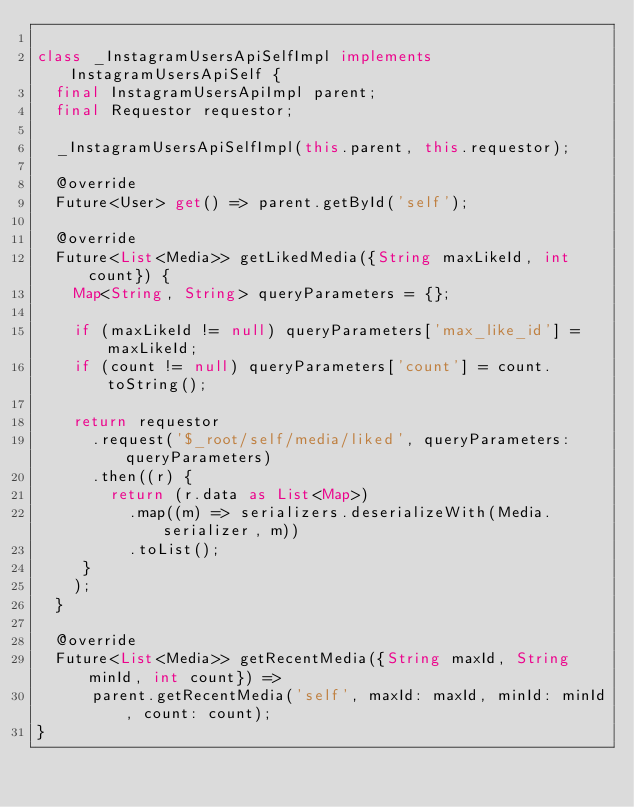<code> <loc_0><loc_0><loc_500><loc_500><_Dart_>
class _InstagramUsersApiSelfImpl implements InstagramUsersApiSelf {
  final InstagramUsersApiImpl parent;
  final Requestor requestor;

  _InstagramUsersApiSelfImpl(this.parent, this.requestor);

  @override
  Future<User> get() => parent.getById('self');

  @override
  Future<List<Media>> getLikedMedia({String maxLikeId, int count}) {
    Map<String, String> queryParameters = {};

    if (maxLikeId != null) queryParameters['max_like_id'] = maxLikeId;
    if (count != null) queryParameters['count'] = count.toString();

    return requestor
      .request('$_root/self/media/liked', queryParameters: queryParameters)
      .then((r) {
        return (r.data as List<Map>)
          .map((m) => serializers.deserializeWith(Media.serializer, m))
          .toList();
     }
    );
  }

  @override
  Future<List<Media>> getRecentMedia({String maxId, String minId, int count}) =>
      parent.getRecentMedia('self', maxId: maxId, minId: minId, count: count);
}
</code> 